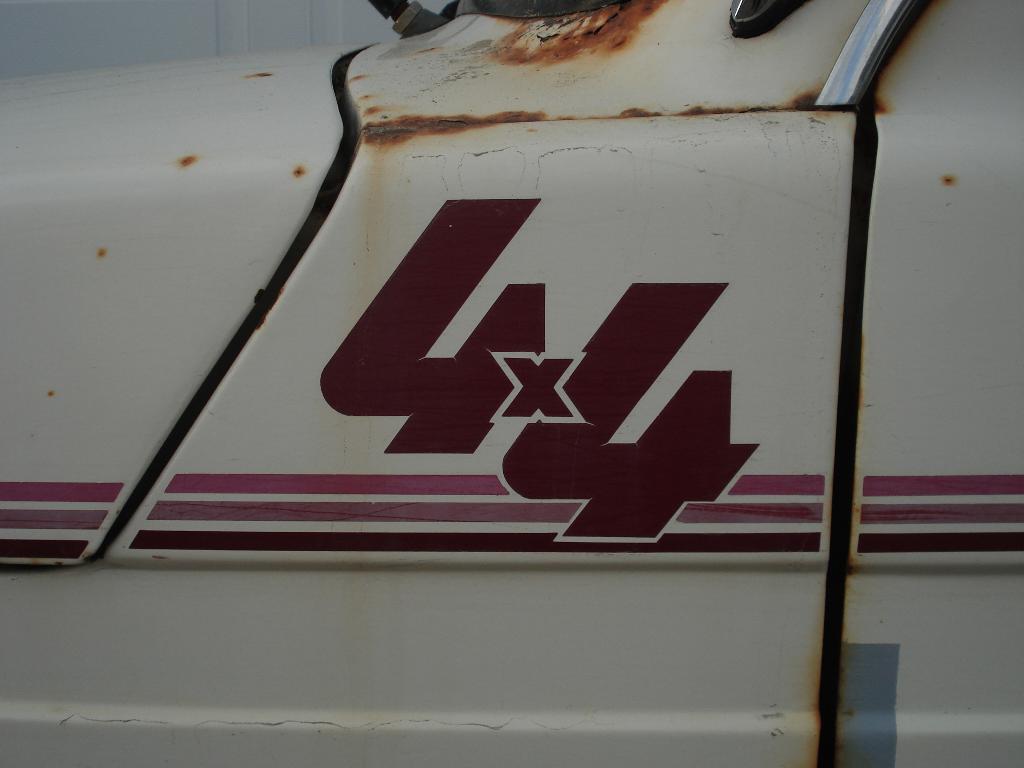In one or two sentences, can you explain what this image depicts? In this image we can see a motor vehicle. 